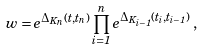Convert formula to latex. <formula><loc_0><loc_0><loc_500><loc_500>w = e ^ { \Delta _ { K _ { n } } ( t , t _ { n } ) } \prod _ { i = 1 } ^ { n } e ^ { \Delta _ { K _ { i - 1 } } ( t _ { i } , t _ { i - 1 } ) } \, ,</formula> 